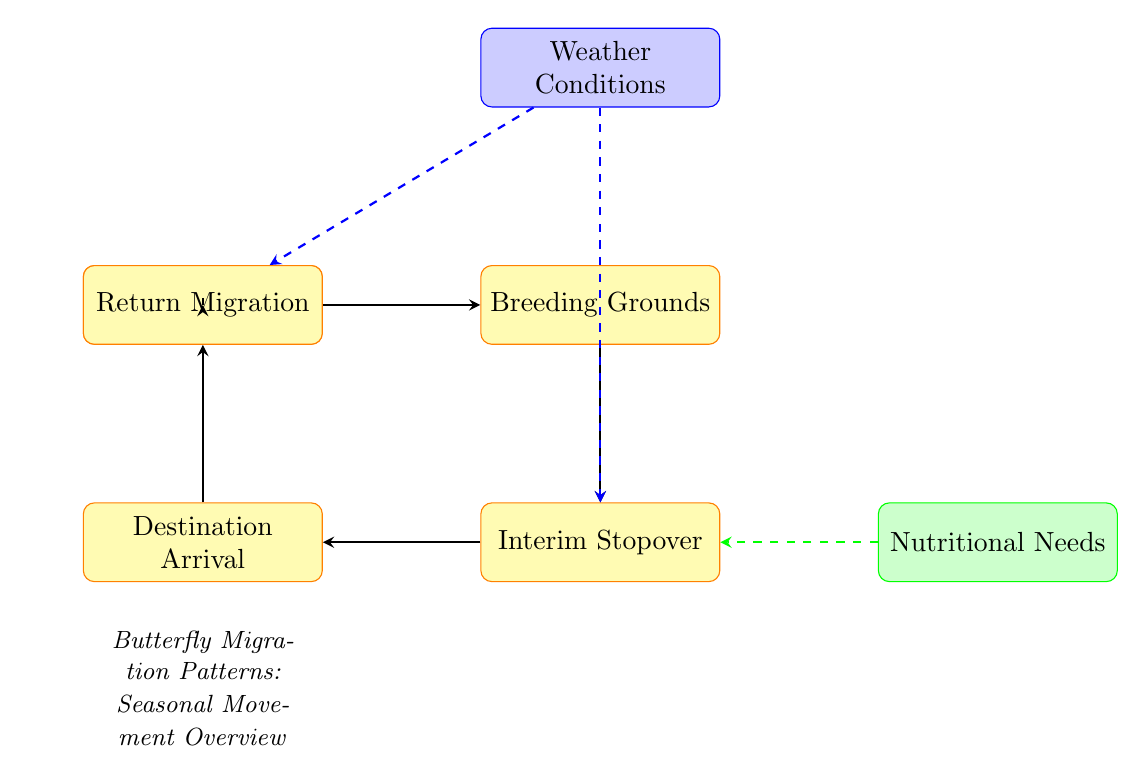What is the first step in the migration process? The first step in the migration process is indicated by the node labeled "Start of Migration." This node represents the initial trigger points for butterfly migration, such as temperature changes or daylight shifts.
Answer: Start of Migration How many main nodes are in the diagram? Counting all the nodes depicted in the diagram, there are a total of 7 main nodes representing different stages or processes in butterfly migration.
Answer: 7 What describes the arrival at breeding grounds? The 'Breeding Grounds' node specifically highlights that migratory butterflies head toward locations where they reproduce. An example, such as Monarch butterflies migrating to Mexico, is provided to illustrate this point.
Answer: Breeding Grounds What influences the butterfly migration process according to the diagram? The "Weather Conditions" node, shown above the 'Breeding Grounds' node, indicates that migration is influenced by weather patterns and conditions, such as favorable winds.
Answer: Weather Conditions What is the role of interim stopovers during migration? The 'Interim Stopover' node describes a crucial part of the migration where butterflies rest and feed, providing them with necessary sustenance before continuing their journey.
Answer: Rest and feed What happens after butterflies reach their destination? After reaching their destination, illustrated in the 'Destination Arrival' node, butterflies often find a suitable habitat for breeding or overwintering. This step indicates the importance of the destination in the overall migration process.
Answer: Find suitable habitat How do butterflies return after the breeding season? The node labeled 'Return Migration' signifies that butterflies begin their return journey to their original habitats after completing their breeding or overwintering activities, demonstrating a cyclical aspect of migration.
Answer: Return to original habitats 